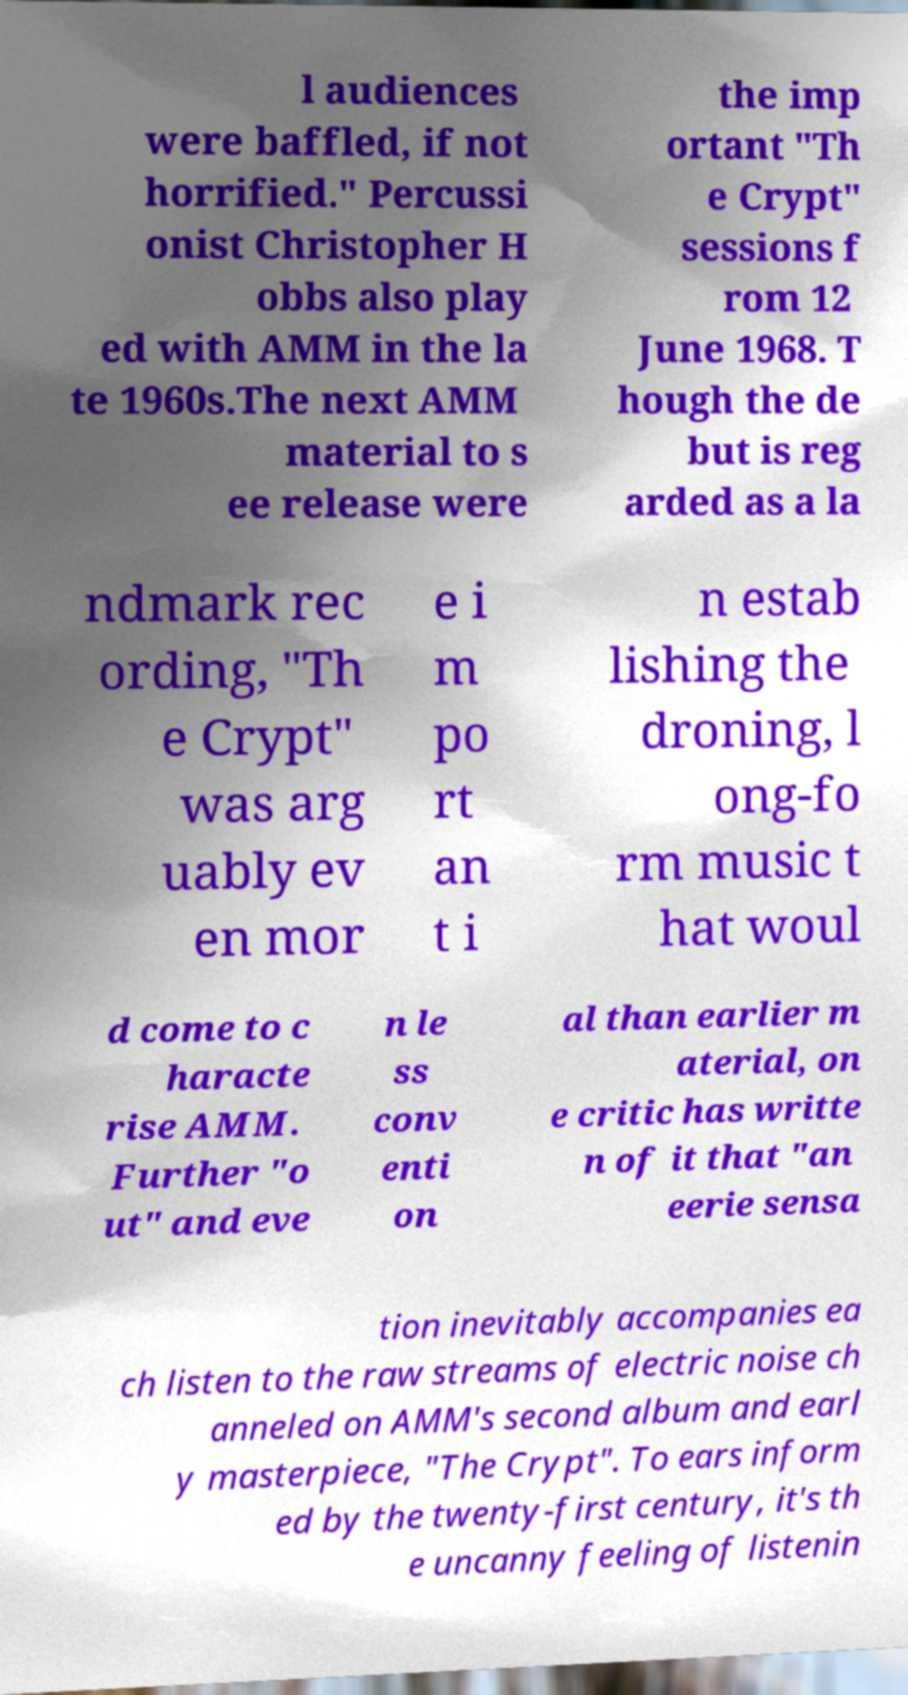Can you read and provide the text displayed in the image?This photo seems to have some interesting text. Can you extract and type it out for me? l audiences were baffled, if not horrified." Percussi onist Christopher H obbs also play ed with AMM in the la te 1960s.The next AMM material to s ee release were the imp ortant "Th e Crypt" sessions f rom 12 June 1968. T hough the de but is reg arded as a la ndmark rec ording, "Th e Crypt" was arg uably ev en mor e i m po rt an t i n estab lishing the droning, l ong-fo rm music t hat woul d come to c haracte rise AMM. Further "o ut" and eve n le ss conv enti on al than earlier m aterial, on e critic has writte n of it that "an eerie sensa tion inevitably accompanies ea ch listen to the raw streams of electric noise ch anneled on AMM's second album and earl y masterpiece, "The Crypt". To ears inform ed by the twenty-first century, it's th e uncanny feeling of listenin 